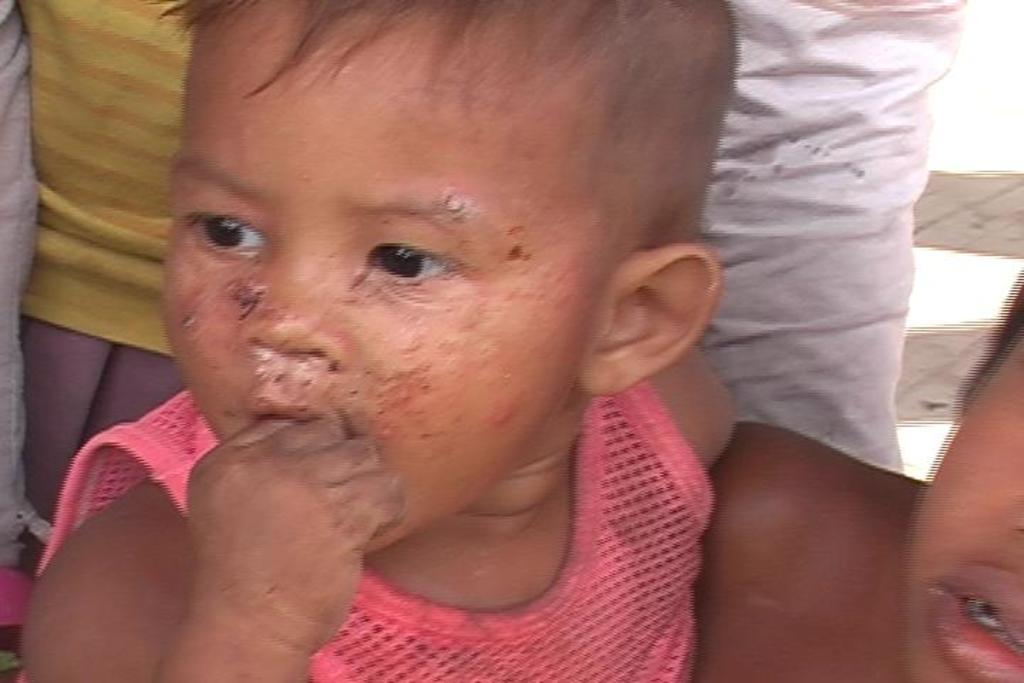What is the main subject of the image? There is a child in the image. Are there any other people in the image? Yes, there are two other persons standing behind the child. What type of wheel can be seen attached to the child in the image? There is no wheel present in the image, and the child is not attached to any wheel. 